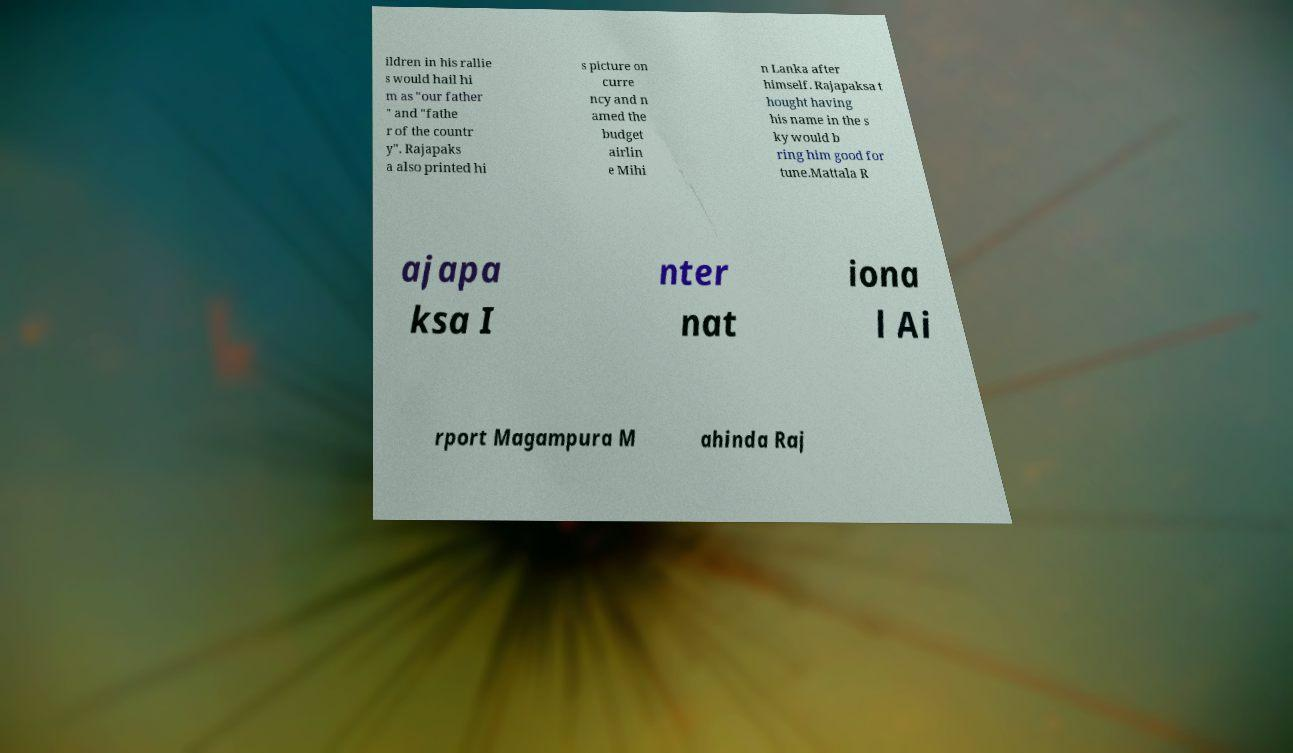Please identify and transcribe the text found in this image. ildren in his rallie s would hail hi m as "our father " and "fathe r of the countr y". Rajapaks a also printed hi s picture on curre ncy and n amed the budget airlin e Mihi n Lanka after himself. Rajapaksa t hought having his name in the s ky would b ring him good for tune.Mattala R ajapa ksa I nter nat iona l Ai rport Magampura M ahinda Raj 